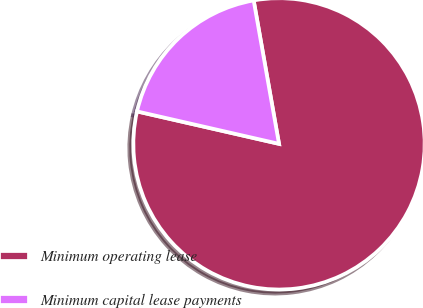Convert chart. <chart><loc_0><loc_0><loc_500><loc_500><pie_chart><fcel>Minimum operating lease<fcel>Minimum capital lease payments<nl><fcel>81.36%<fcel>18.64%<nl></chart> 